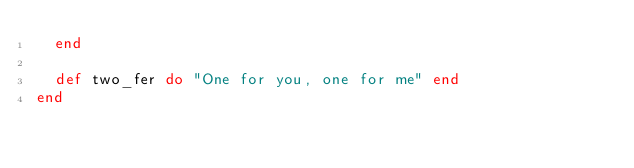<code> <loc_0><loc_0><loc_500><loc_500><_Elixir_>  end

  def two_fer do "One for you, one for me" end
end
</code> 